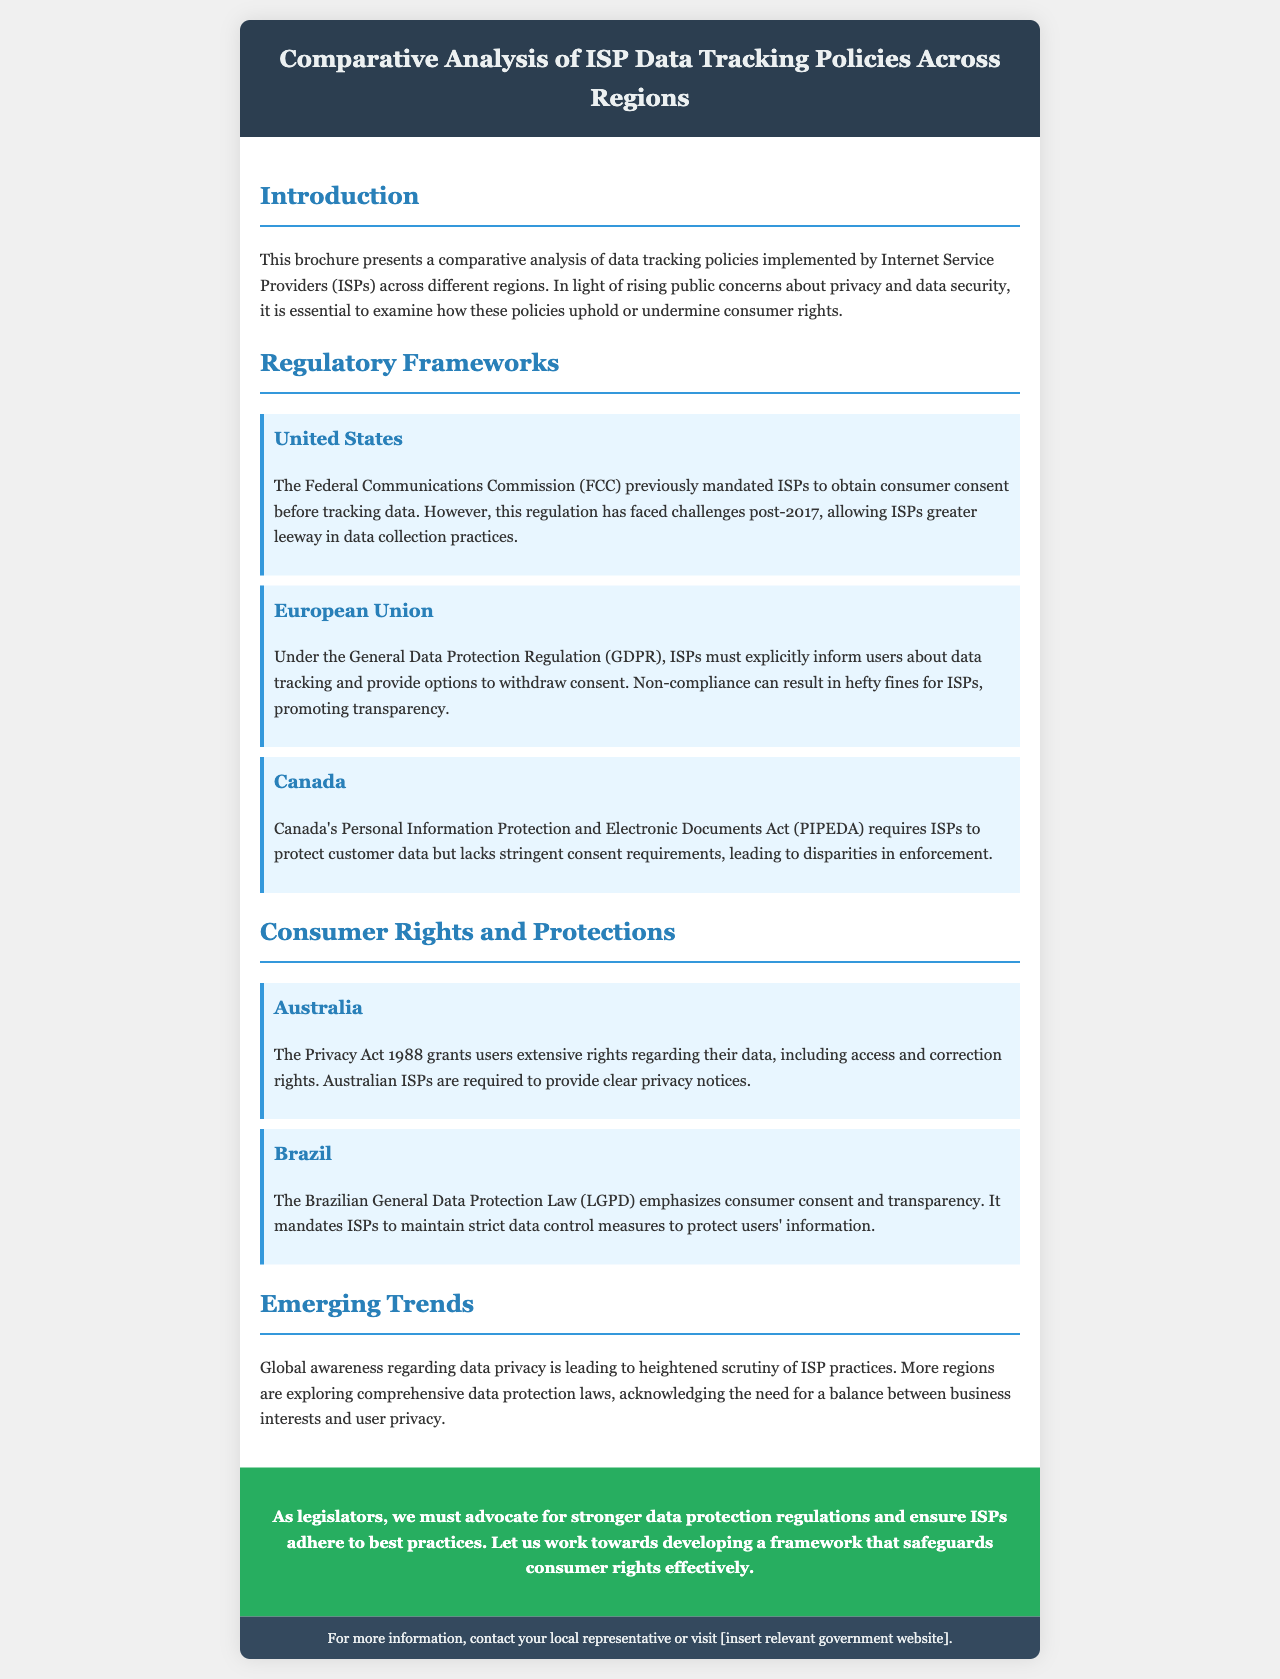What is the primary focus of the brochure? The brochure presents a comparative analysis of data tracking policies to uphold or undermine consumer rights.
Answer: Comparative analysis of data tracking policies Which regulatory framework does the European Union follow? The document states that the EU follows the General Data Protection Regulation (GDPR).
Answer: General Data Protection Regulation (GDPR) What must ISPs in Canada adhere to regarding data protection? Canadian ISPs must adhere to the Personal Information Protection and Electronic Documents Act (PIPEDA).
Answer: Personal Information Protection and Electronic Documents Act (PIPEDA) What does the Australian Privacy Act grant users? The Privacy Act 1988 grants users extensive rights regarding their data, including access and correction rights.
Answer: Access and correction rights What is a mention of an emerging trend noted in the document? The document notes that global awareness regarding data privacy is leading to heightened scrutiny of ISP practices.
Answer: Heightened scrutiny of ISP practices How can non-compliance with GDPR affect ISPs? Non-compliance can result in hefty fines for ISPs, thus promoting transparency.
Answer: Hefty fines for ISPs What does the brochure prompt legislators to advocate for? The brochure calls for stronger data protection regulations.
Answer: Stronger data protection regulations What information does the footer suggest for more details? The footer suggests contacting local representatives or visiting a relevant government website for more information.
Answer: Local representatives or relevant government website 